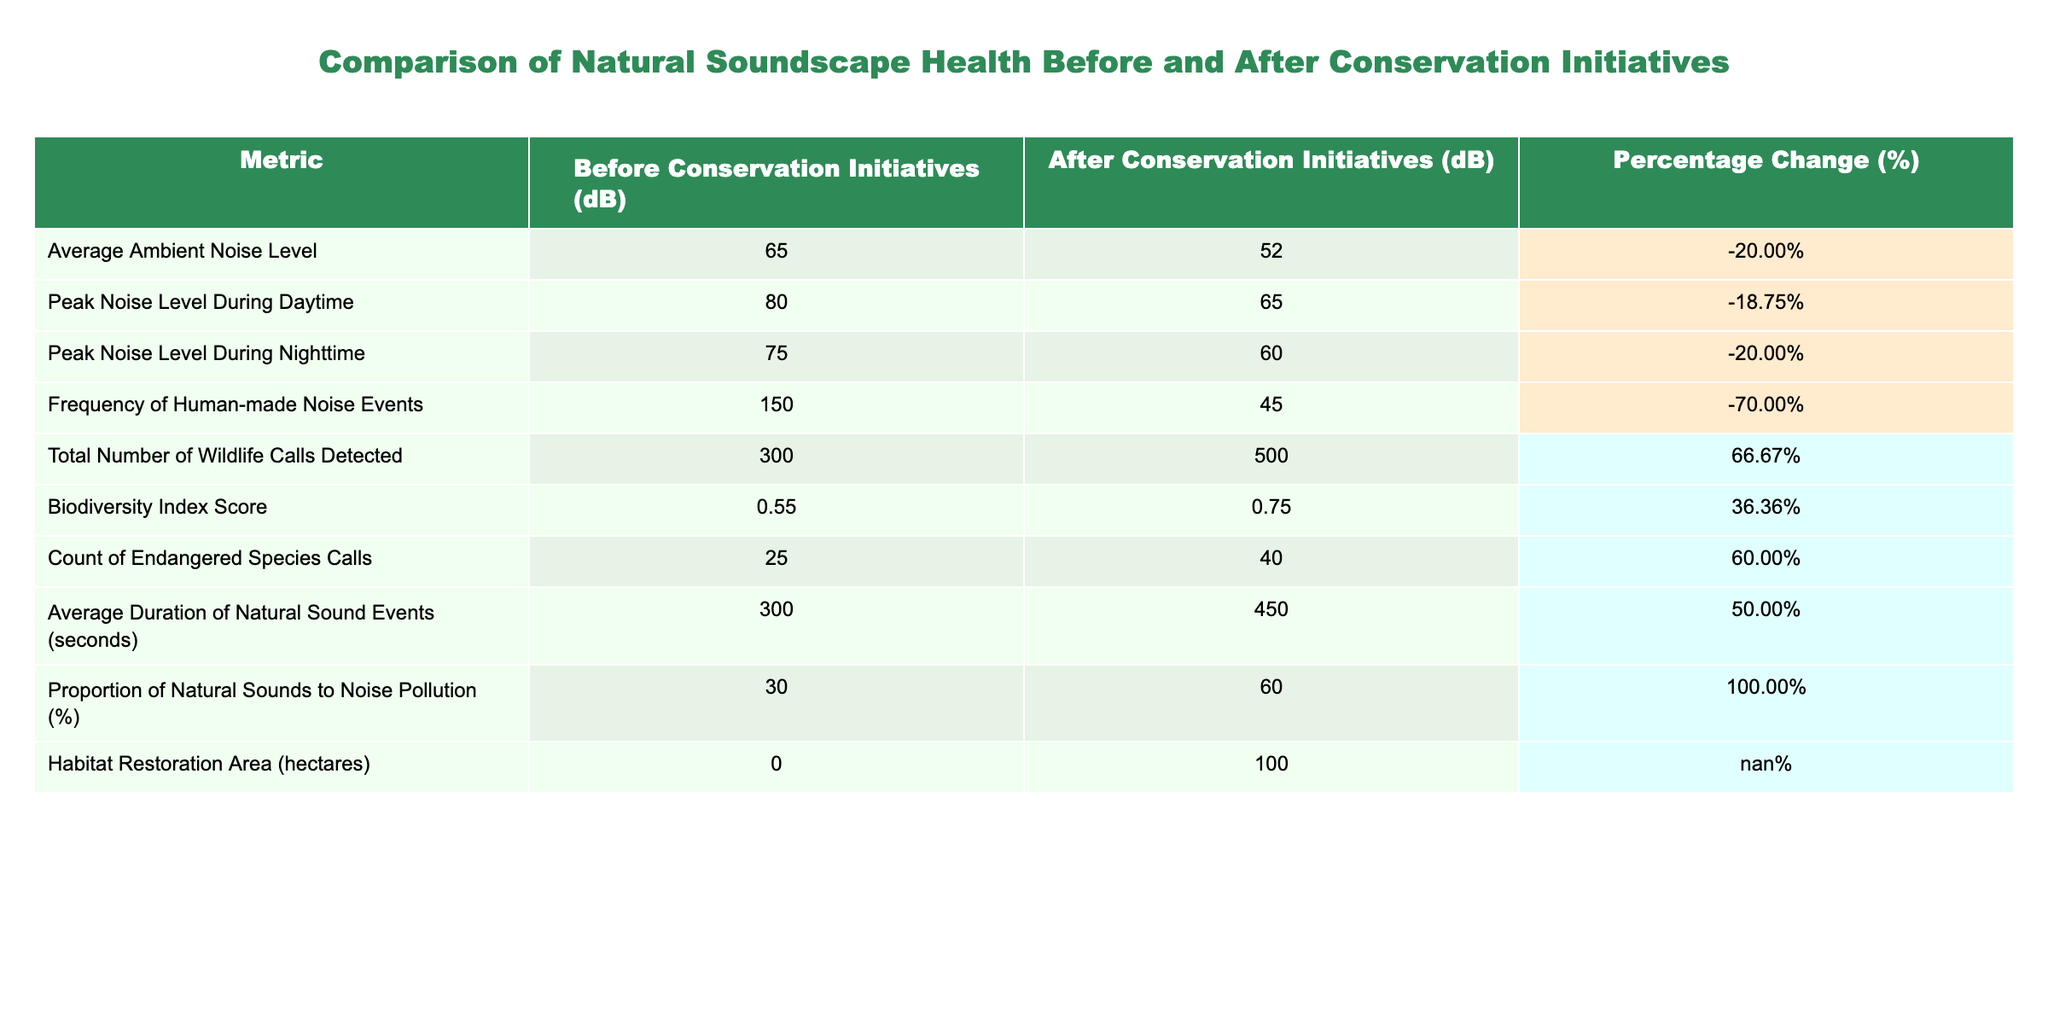What was the average ambient noise level before the conservation initiatives? The table states that the average ambient noise level before conservation initiatives was 65 dB.
Answer: 65 dB What change occurred in the frequency of human-made noise events after the conservation initiatives? The frequency of human-made noise events reduced from 150 to 45 events after the initiatives, showing a significant decimation of noise pollution.
Answer: Reduced by 70% What is the percentage change in total number of wildlife calls detected? The total number of wildlife calls detected rose from 300 to 500. To find the percentage change, use the formula: ((500 - 300) / 300) * 100 = 66.67%.
Answer: 66.67% Did the biodiversity index score improve after the conservation initiatives? Yes, the biodiversity index score increased from 0.55 to 0.75, indicating an improvement in biodiversity.
Answer: Yes What is the difference in peak noise level during daytime before and after the initiatives? The peak noise level during daytime decreased from 80 dB to 65 dB after the initiatives. The difference is 80 - 65 = 15 dB.
Answer: 15 dB How many more endangered species calls were detected after the conservation initiatives compared to before? There were 40 endangered species calls detected after the initiatives compared to 25 before, resulting in an increase of 40 - 25 = 15 calls.
Answer: 15 calls What was the change in the proportion of natural sounds to noise pollution? The proportion of natural sounds to noise pollution increased from 30% to 60%. This indicates a positive change in the natural soundscape quality.
Answer: Increased by 30% How much area was restored in hectares as a result of the conservation initiatives? The table indicates that the habitat restoration area increased to 100 hectares after the conservation initiatives.
Answer: 100 hectares Was the average duration of natural sound events longer before or after the conservation initiatives? The average duration of natural sound events increased from 300 seconds to 450 seconds post-initiatives, confirming that it was longer after the initiatives.
Answer: Longer after the initiatives 